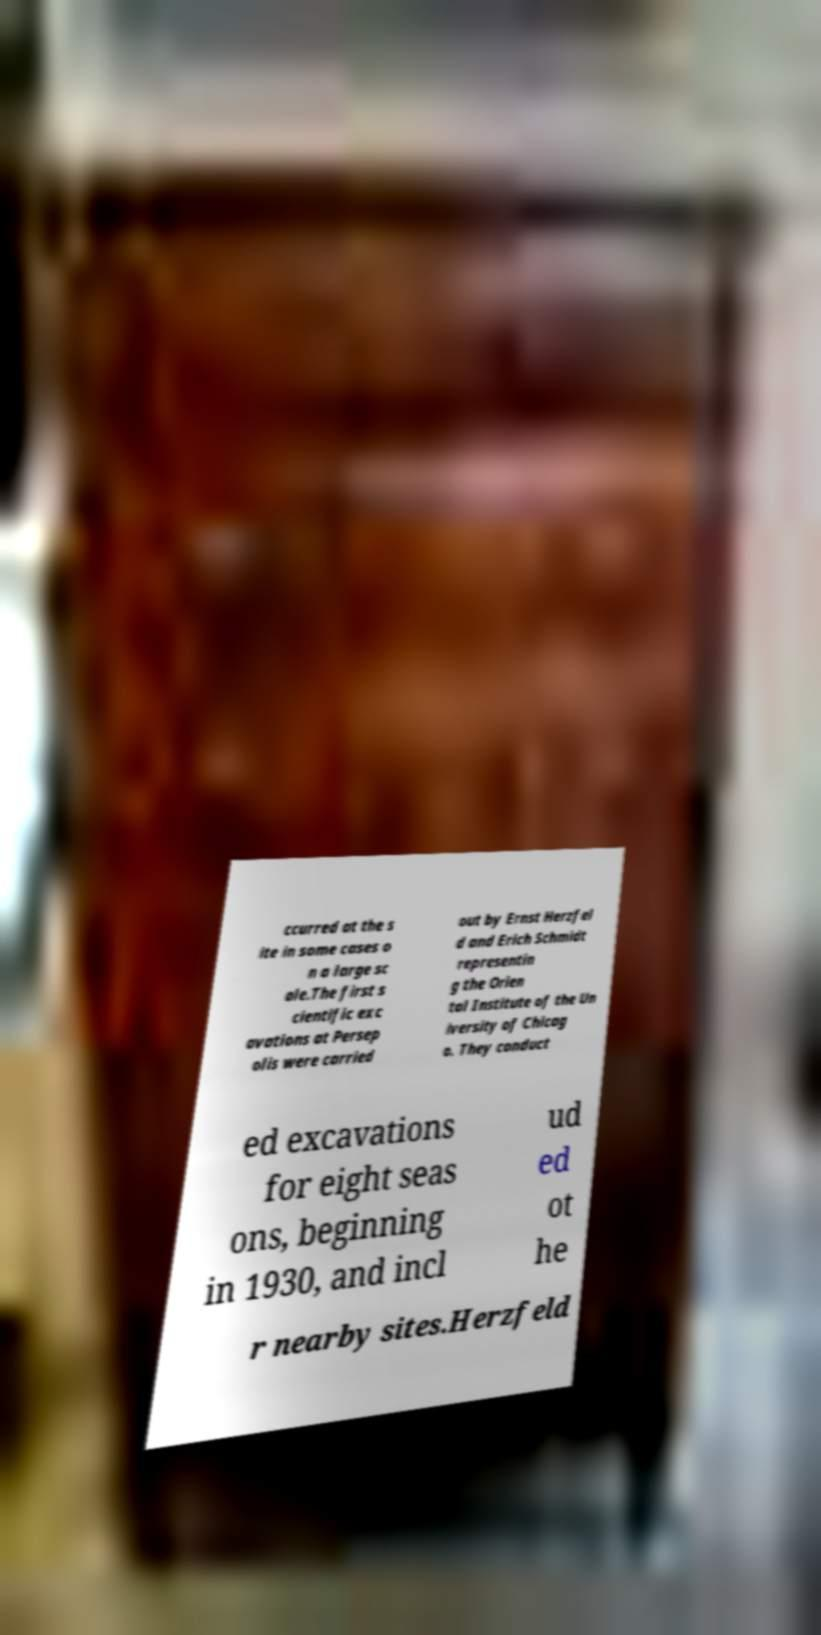Could you extract and type out the text from this image? ccurred at the s ite in some cases o n a large sc ale.The first s cientific exc avations at Persep olis were carried out by Ernst Herzfel d and Erich Schmidt representin g the Orien tal Institute of the Un iversity of Chicag o. They conduct ed excavations for eight seas ons, beginning in 1930, and incl ud ed ot he r nearby sites.Herzfeld 